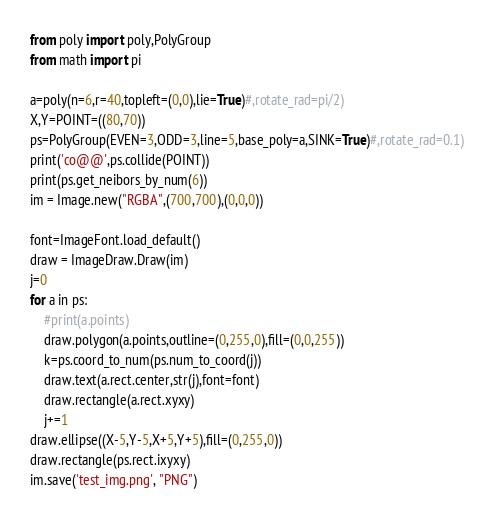Convert code to text. <code><loc_0><loc_0><loc_500><loc_500><_Python_>from poly import poly,PolyGroup
from math import pi

a=poly(n=6,r=40,topleft=(0,0),lie=True)#,rotate_rad=pi/2)
X,Y=POINT=((80,70))
ps=PolyGroup(EVEN=3,ODD=3,line=5,base_poly=a,SINK=True)#,rotate_rad=0.1)
print('co@@',ps.collide(POINT))
print(ps.get_neibors_by_num(6))
im = Image.new("RGBA",(700,700),(0,0,0))

font=ImageFont.load_default()
draw = ImageDraw.Draw(im)
j=0
for a in ps:
    #print(a.points)
    draw.polygon(a.points,outline=(0,255,0),fill=(0,0,255))
    k=ps.coord_to_num(ps.num_to_coord(j))
    draw.text(a.rect.center,str(j),font=font)
    draw.rectangle(a.rect.xyxy)
    j+=1
draw.ellipse((X-5,Y-5,X+5,Y+5),fill=(0,255,0))
draw.rectangle(ps.rect.ixyxy)
im.save('test_img.png', "PNG")
</code> 